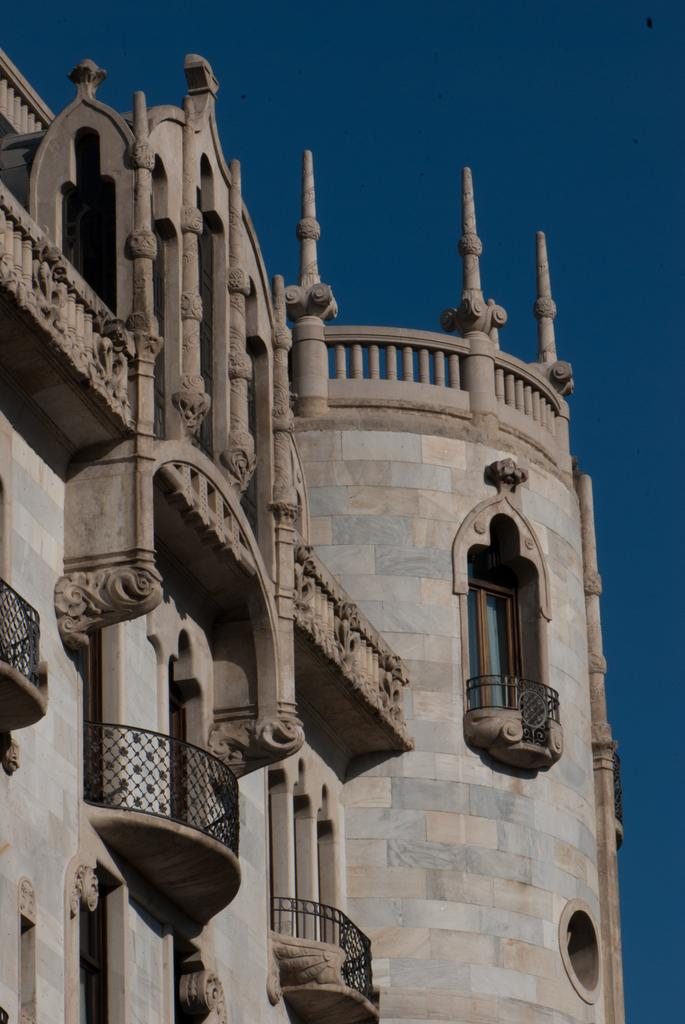What type of structure is present in the image? There is a building in the picture. Can you describe any specific features of the building? The building has three balconies. What can be seen through one of the openings in the building? There is a glass window in the picture. What is visible at the top of the image? The sky is visible at the top of the picture. What type of vegetable is being delivered in a parcel in the image? There is no vegetable or parcel present in the image. How does the loss of the vegetable affect the image? There is no loss of a vegetable or any other object mentioned in the image, so it does not affect the image. 